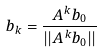<formula> <loc_0><loc_0><loc_500><loc_500>b _ { k } = \frac { A ^ { k } b _ { 0 } } { | | A ^ { k } b _ { 0 } | | }</formula> 